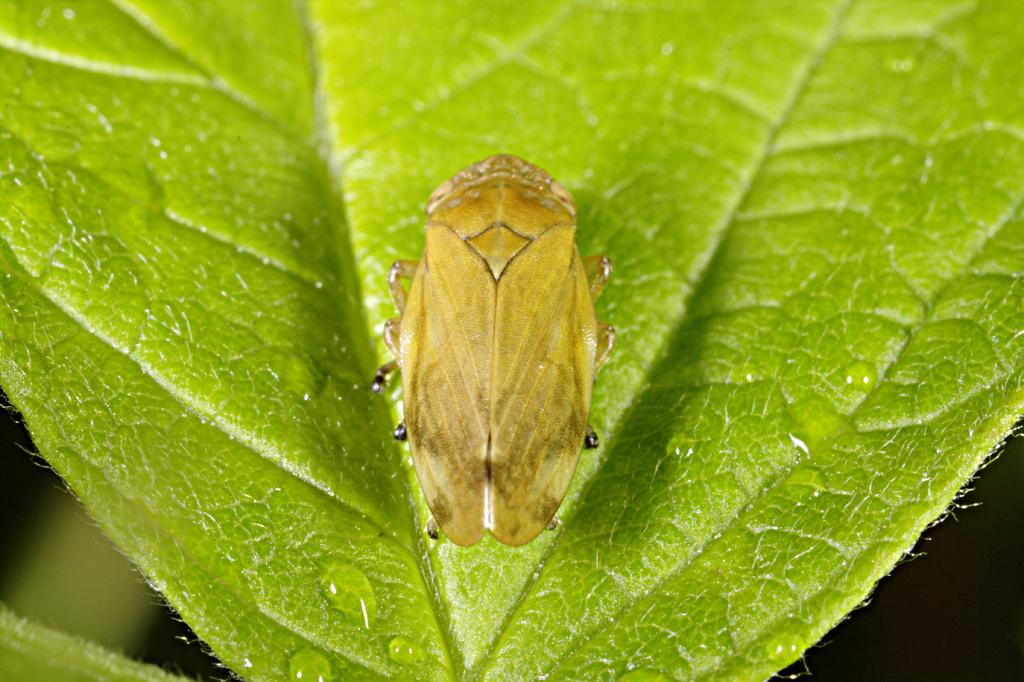What is present in the image? There is an insect in the image. Where is the insect located? The insect is on a leaf. What is the color of the insect? The insect is brown in color. Can you describe the background of the image? The background of the image is blurred. What is the interest rate for the mice in the image? There are no mice present in the image, and therefore no interest rate can be determined. 